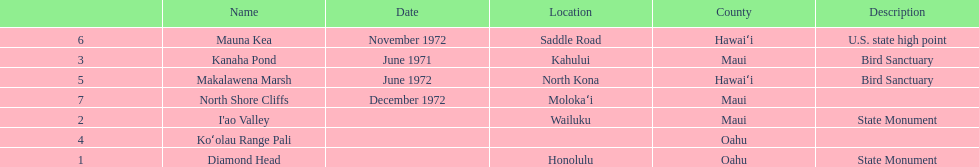Is kanaha pond a state monument or a bird sanctuary? Bird Sanctuary. 